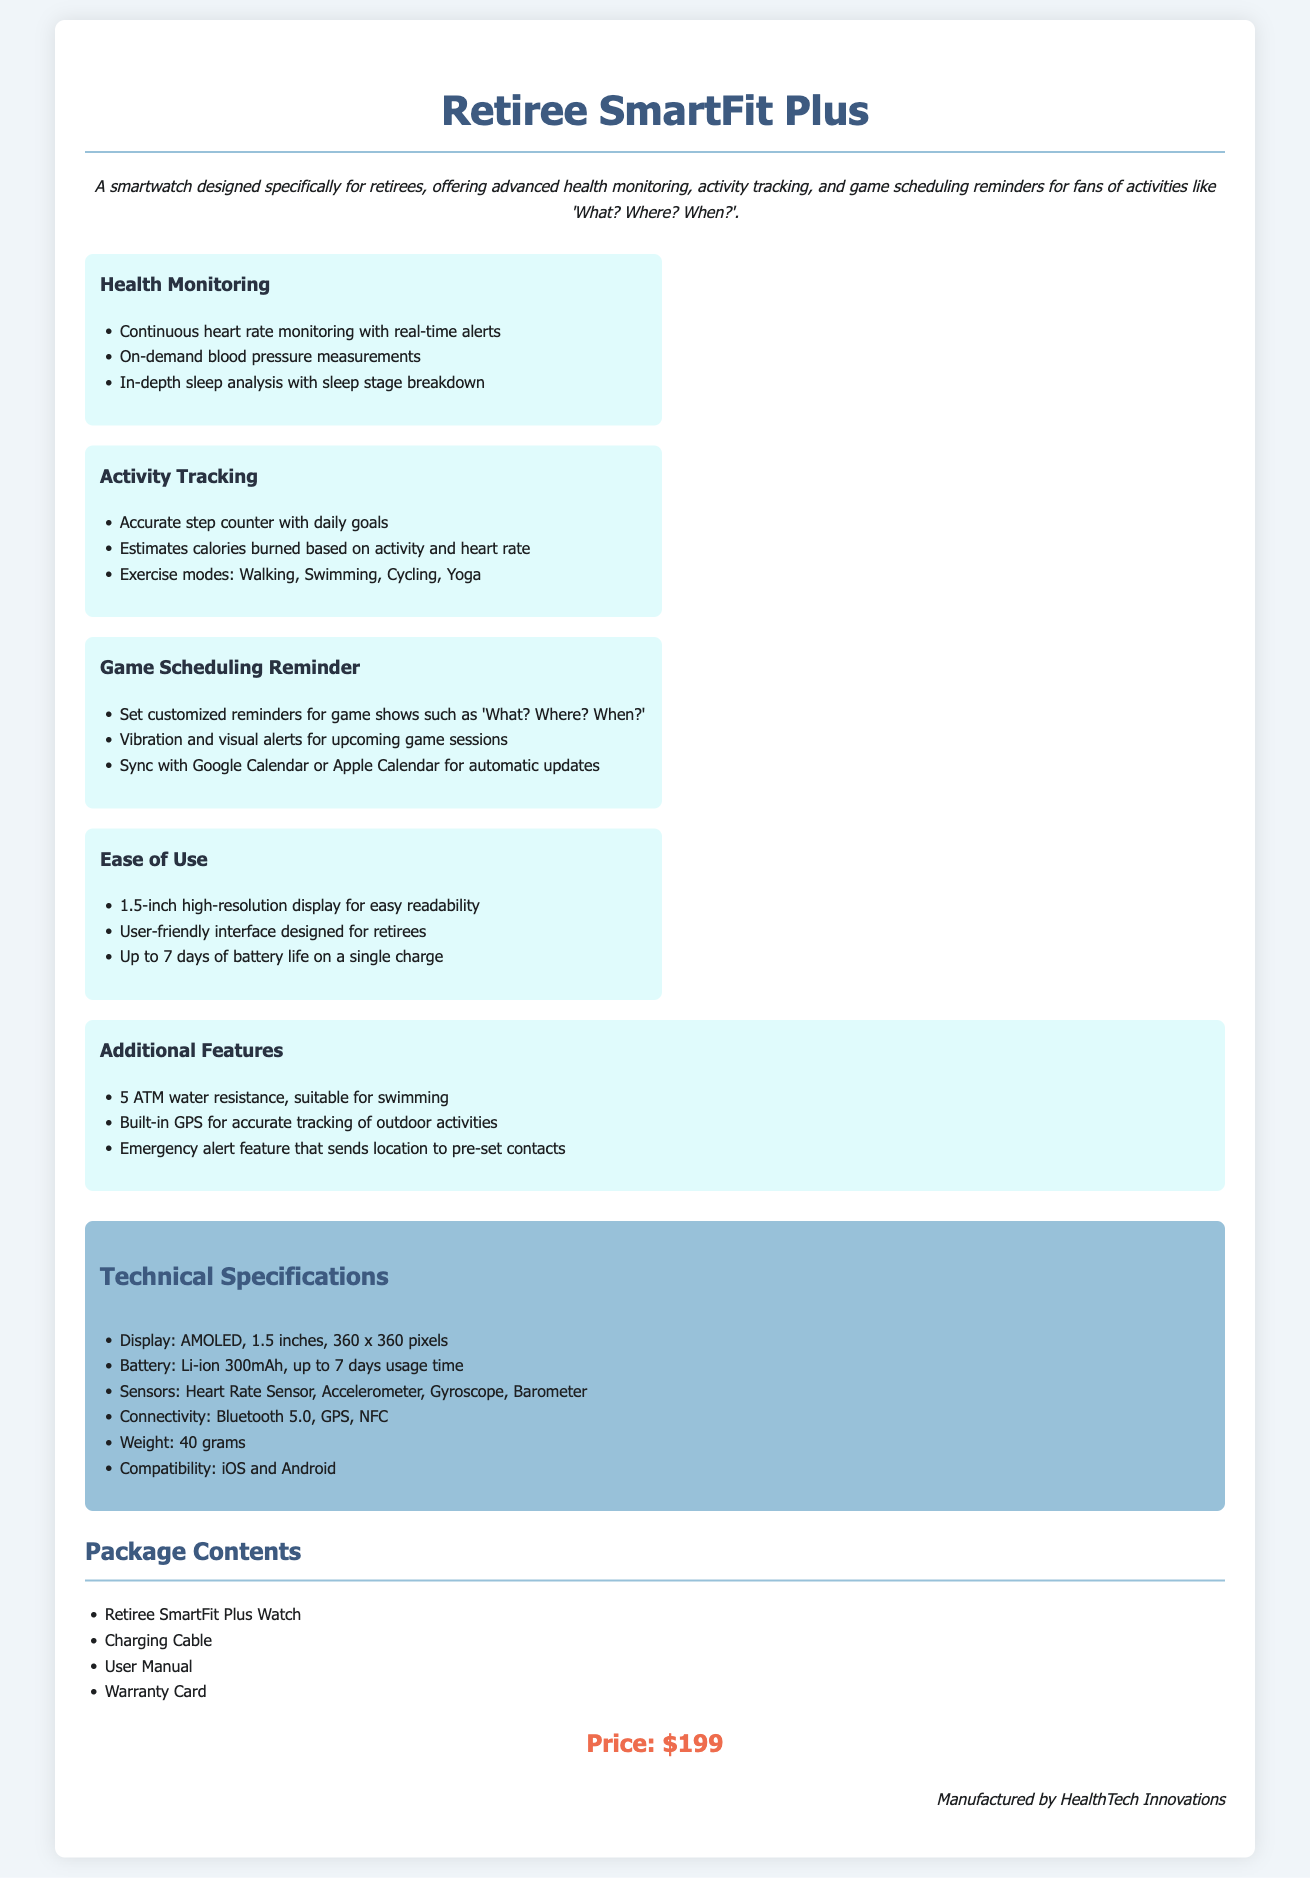what is the product name? The product name is mentioned at the top of the document, highlighting the specific smartwatch designed for retirees.
Answer: Retiree SmartFit Plus what is the price of the smartwatch? The price is listed in a designated section of the document, indicating the cost of the product.
Answer: $199 how long does the smartwatch battery last? The battery life is specified under the Ease of Use section, providing information about usage time on a single charge.
Answer: Up to 7 days which feature supports health monitoring? This refers to a specific capability highlighted within the Health Monitoring feature section of the document.
Answer: Continuous heart rate monitoring what types of exercise modes does the smartwatch support? Exercise modes are mentioned under the Activity Tracking section, listing available physical activities that can be tracked.
Answer: Walking, Swimming, Cycling, Yoga how does the smartwatch alert users about game schedules? This describes the functionality related to reminders for game shows, indicating how users receive notifications.
Answer: Vibration and visual alerts what sensors are included in the smartwatch? The Technical Specifications section lists the sensors that come with the smartwatch for monitoring various health metrics.
Answer: Heart Rate Sensor, Accelerometer, Gyroscope, Barometer what is the water resistance level of the smartwatch? The water resistance quality of the smartwatch is mentioned in the Additional Features section, specifying its suitability for water activities.
Answer: 5 ATM what content is included in the package? The Package Contents section outlines the items that come along with the purchase of the smartwatch.
Answer: Retiree SmartFit Plus Watch, Charging Cable, User Manual, Warranty Card 